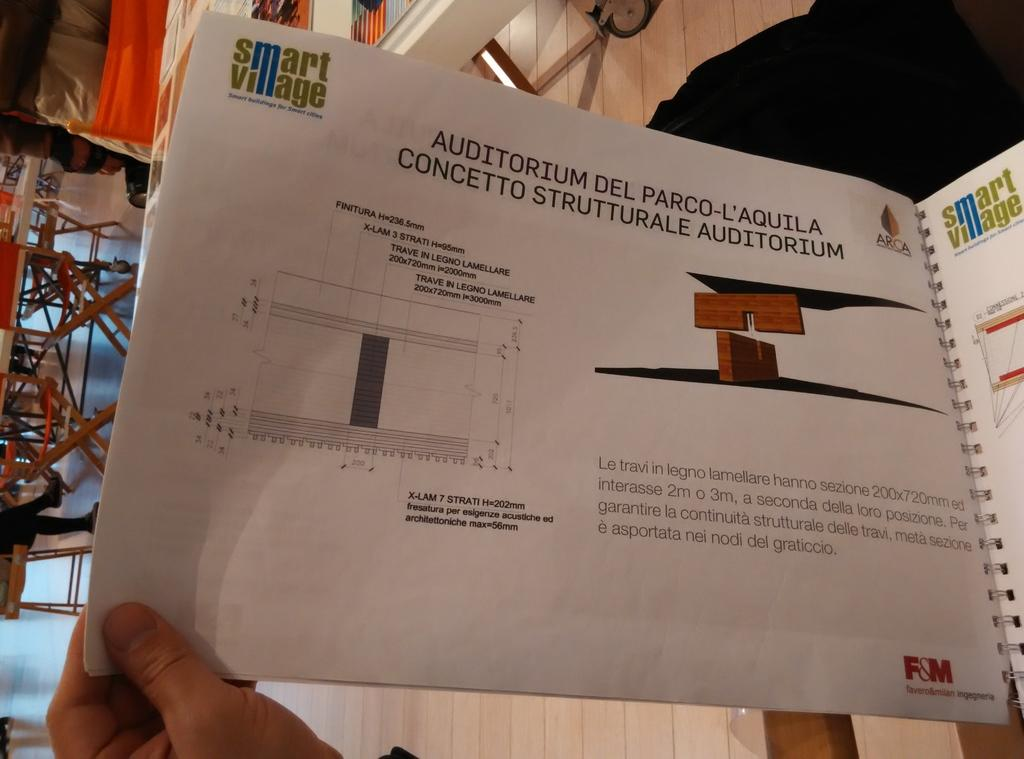<image>
Offer a succinct explanation of the picture presented. An open book with diagrams and info about the Auditorium Del Parco-L'Aquila Concetto Strutturale Auditorium. 